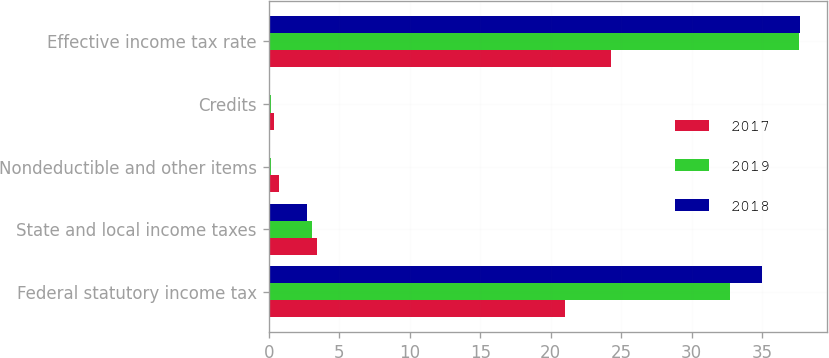Convert chart. <chart><loc_0><loc_0><loc_500><loc_500><stacked_bar_chart><ecel><fcel>Federal statutory income tax<fcel>State and local income taxes<fcel>Nondeductible and other items<fcel>Credits<fcel>Effective income tax rate<nl><fcel>2017<fcel>21<fcel>3.4<fcel>0.7<fcel>0.4<fcel>24.3<nl><fcel>2019<fcel>32.7<fcel>3.1<fcel>0.2<fcel>0.2<fcel>37.6<nl><fcel>2018<fcel>35<fcel>2.7<fcel>0.1<fcel>0.1<fcel>37.7<nl></chart> 